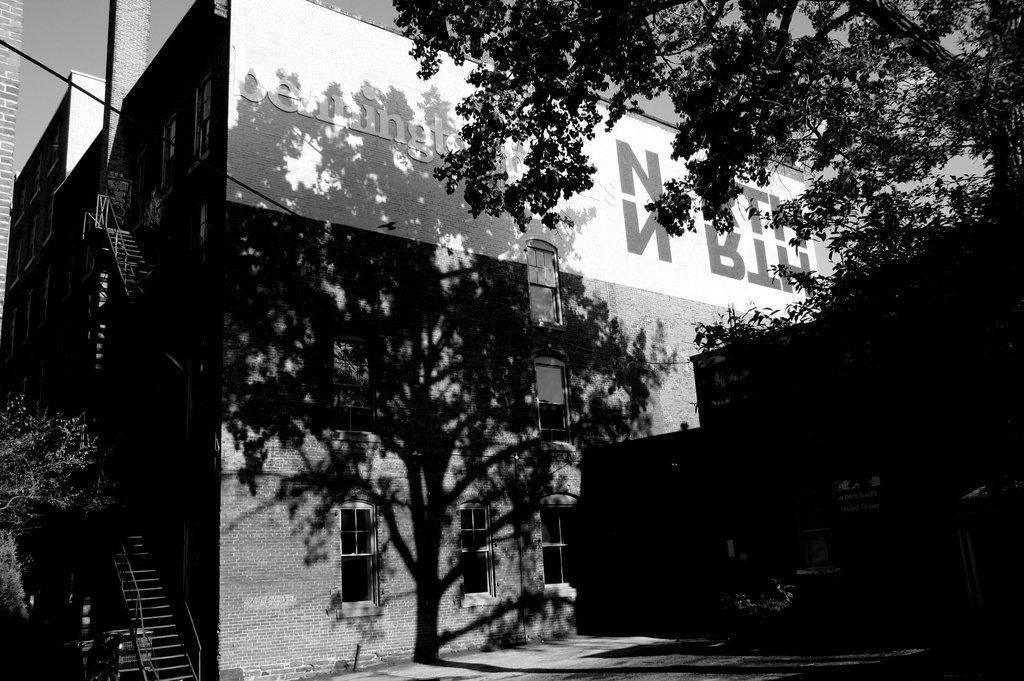Describe this image in one or two sentences. In this picture we can see the buildings. On the right we can see the tree near to the wall. On the left we can see steel stairs. At the top there is a sky. In the top left corner we can see the table. 